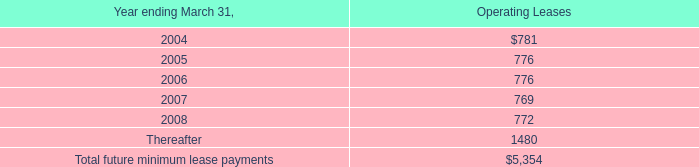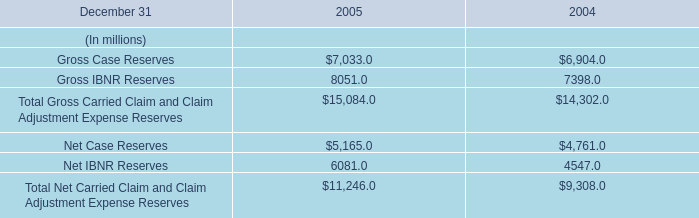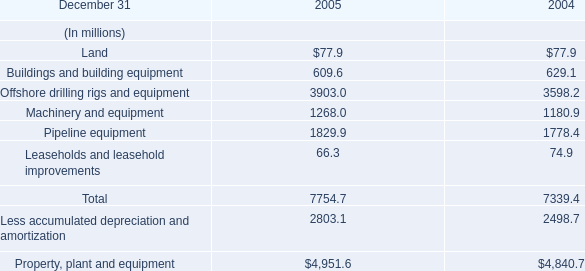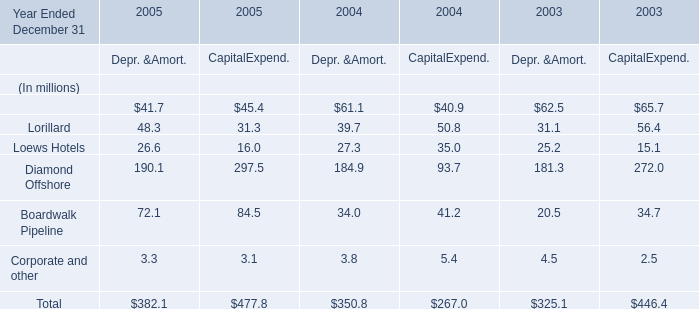What is the growing rate of Diamond Offshore in the year with the most Lorillard? 
Computations: (((190.1 + 297.5) - (184.9 + 93.7)) / (184.9 + 93.7))
Answer: 0.75018. 